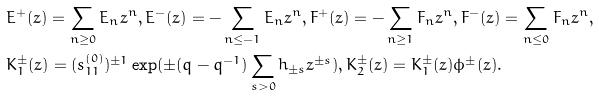Convert formula to latex. <formula><loc_0><loc_0><loc_500><loc_500>& E ^ { + } ( z ) = \sum _ { n \geq 0 } E _ { n } z ^ { n } , E ^ { - } ( z ) = - \sum _ { n \leq - 1 } E _ { n } z ^ { n } , F ^ { + } ( z ) = - \sum _ { n \geq 1 } F _ { n } z ^ { n } , F ^ { - } ( z ) = \sum _ { n \leq 0 } F _ { n } z ^ { n } , \\ & K _ { 1 } ^ { \pm } ( z ) = ( s _ { 1 1 } ^ { ( 0 ) } ) ^ { \pm 1 } \exp ( \pm ( q - q ^ { - 1 } ) \sum _ { s > 0 } h _ { \pm s } z ^ { \pm s } ) , K _ { 2 } ^ { \pm } ( z ) = K _ { 1 } ^ { \pm } ( z ) \phi ^ { \pm } ( z ) .</formula> 